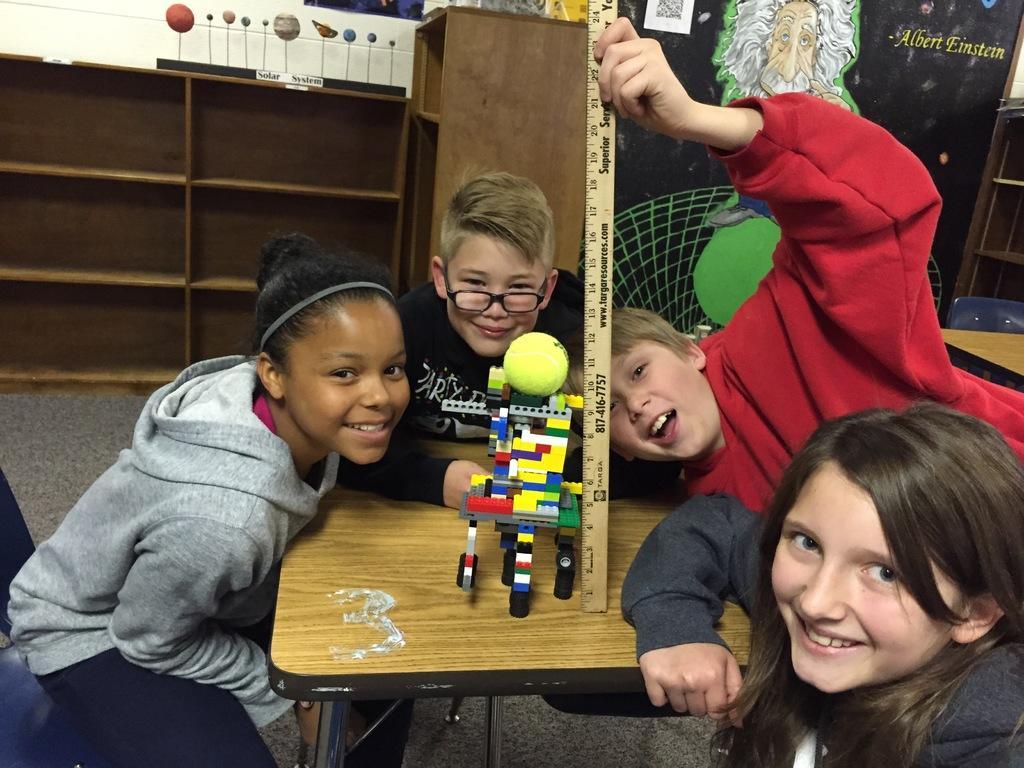Describe this image in one or two sentences. There are children in different color dresses, smiling and sitting around a table on which, there is a toy. One of them is holding a scale and placing it on the table. In the background, there are cupboards, a board and there is white wall. 